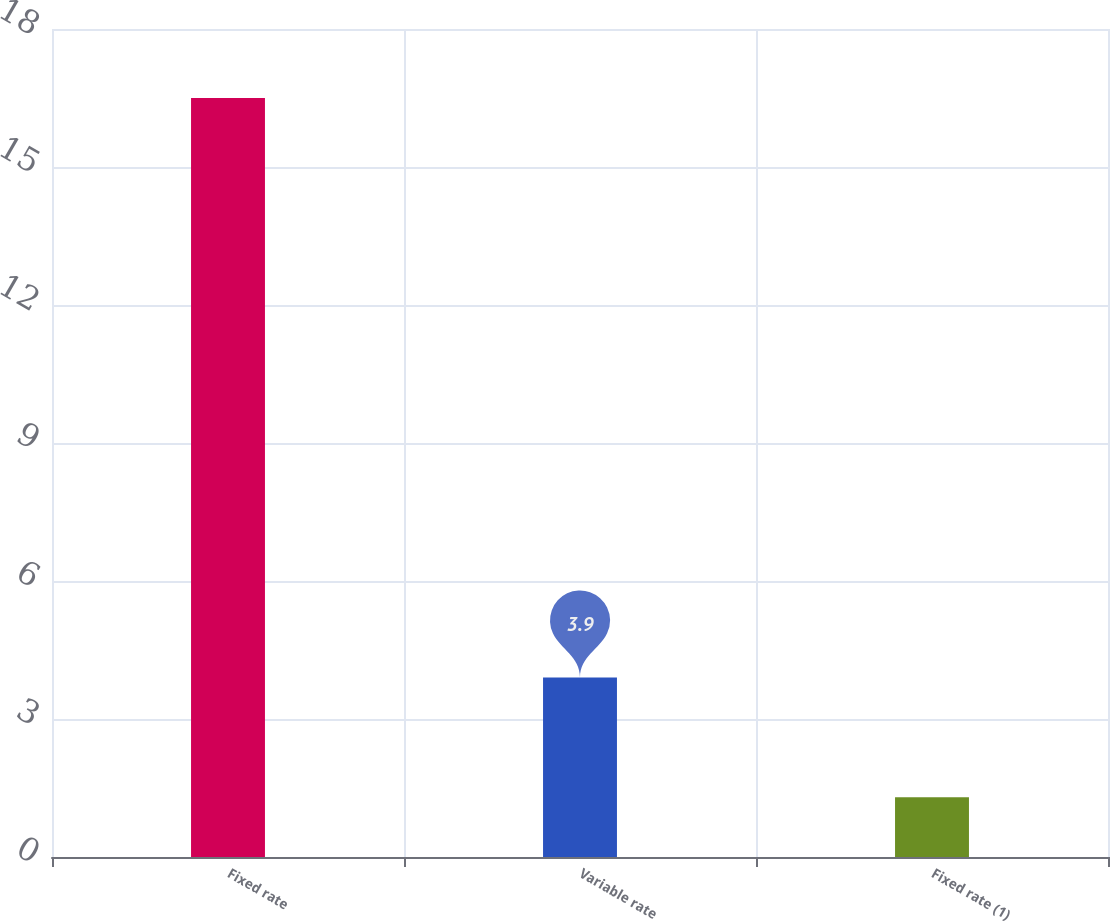<chart> <loc_0><loc_0><loc_500><loc_500><bar_chart><fcel>Fixed rate<fcel>Variable rate<fcel>Fixed rate (1)<nl><fcel>16.5<fcel>3.9<fcel>1.3<nl></chart> 